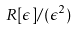Convert formula to latex. <formula><loc_0><loc_0><loc_500><loc_500>R [ \epsilon ] / ( \epsilon ^ { 2 } )</formula> 